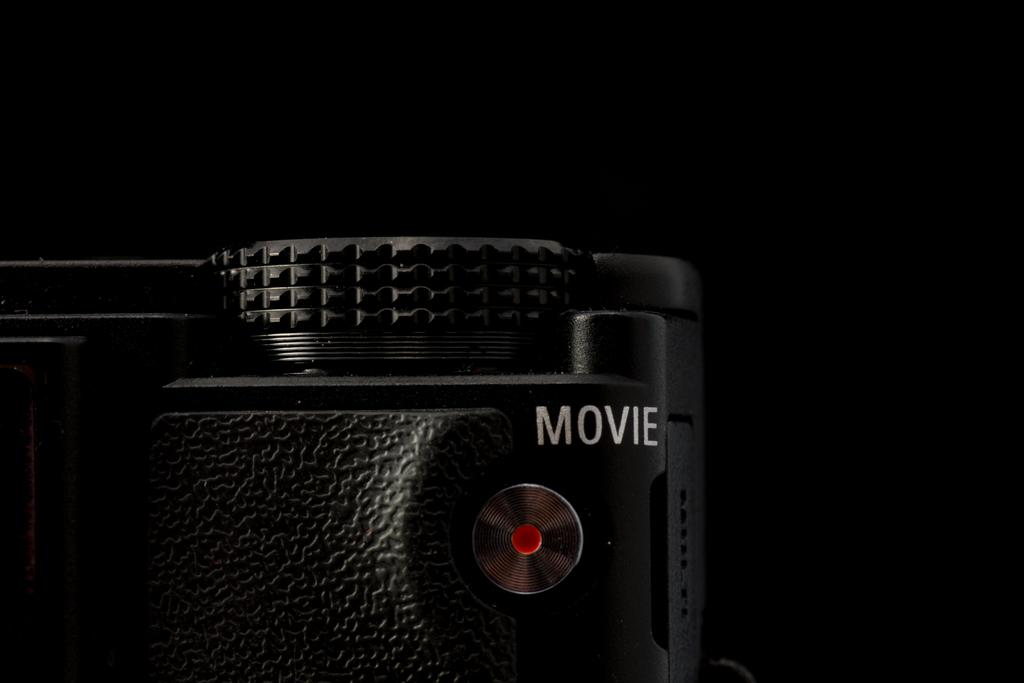What is the main object in the image? There is a camera in the image. What color is the background of the image? The background of the image is black. What type of music can be heard playing in the background of the image? There is no music present in the image, as it only features a camera with a black background. 